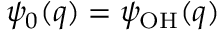Convert formula to latex. <formula><loc_0><loc_0><loc_500><loc_500>\psi _ { 0 } ( q ) = \psi _ { O H } ( q )</formula> 